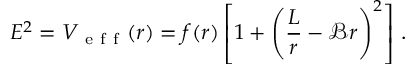Convert formula to latex. <formula><loc_0><loc_0><loc_500><loc_500>E ^ { 2 } = V _ { e f f } ( r ) = f ( r ) \left [ 1 + \left ( \frac { L } { r } - \mathcal { B } r \right ) ^ { 2 } \right ] \, .</formula> 